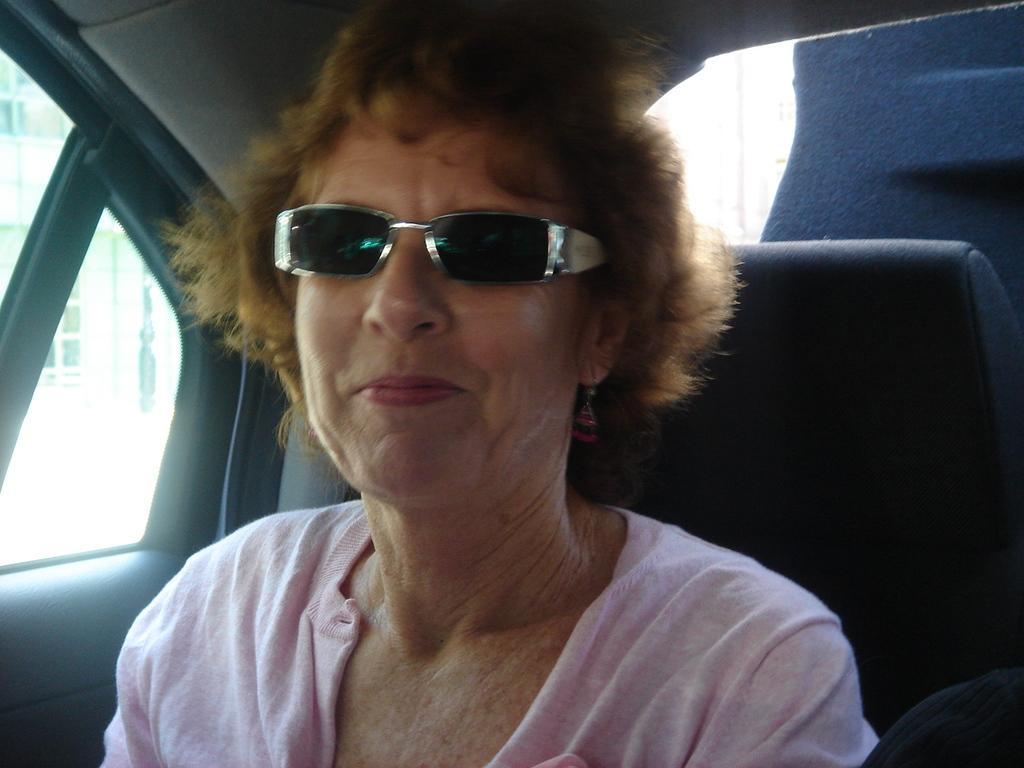Please provide a concise description of this image. In this image I can see the person is sitting inside the vehicle and wearing pink color dress. Back I can see the building. 